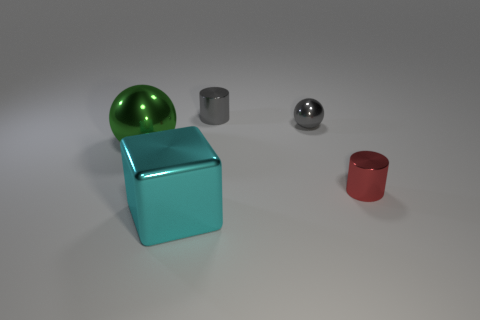Are there the same number of cyan metallic cubes that are on the right side of the red cylinder and big metal blocks that are in front of the large metallic cube?
Ensure brevity in your answer.  Yes. Is there a gray thing that has the same size as the green metallic object?
Make the answer very short. No. How big is the cyan shiny thing?
Offer a very short reply. Large. Is the number of gray metal balls left of the big green metallic ball the same as the number of gray matte spheres?
Your response must be concise. Yes. How many other things are the same color as the tiny ball?
Ensure brevity in your answer.  1. There is a object that is both in front of the green metal thing and behind the big cyan metal cube; what color is it?
Your response must be concise. Red. What size is the ball to the right of the large metal thing that is on the right side of the large green object that is behind the tiny red cylinder?
Offer a terse response. Small. What number of things are either gray cylinders that are behind the big green metal object or objects that are behind the green object?
Your response must be concise. 2. There is a green metallic object; what shape is it?
Ensure brevity in your answer.  Sphere. How many other objects are the same material as the big cube?
Your answer should be very brief. 4. 